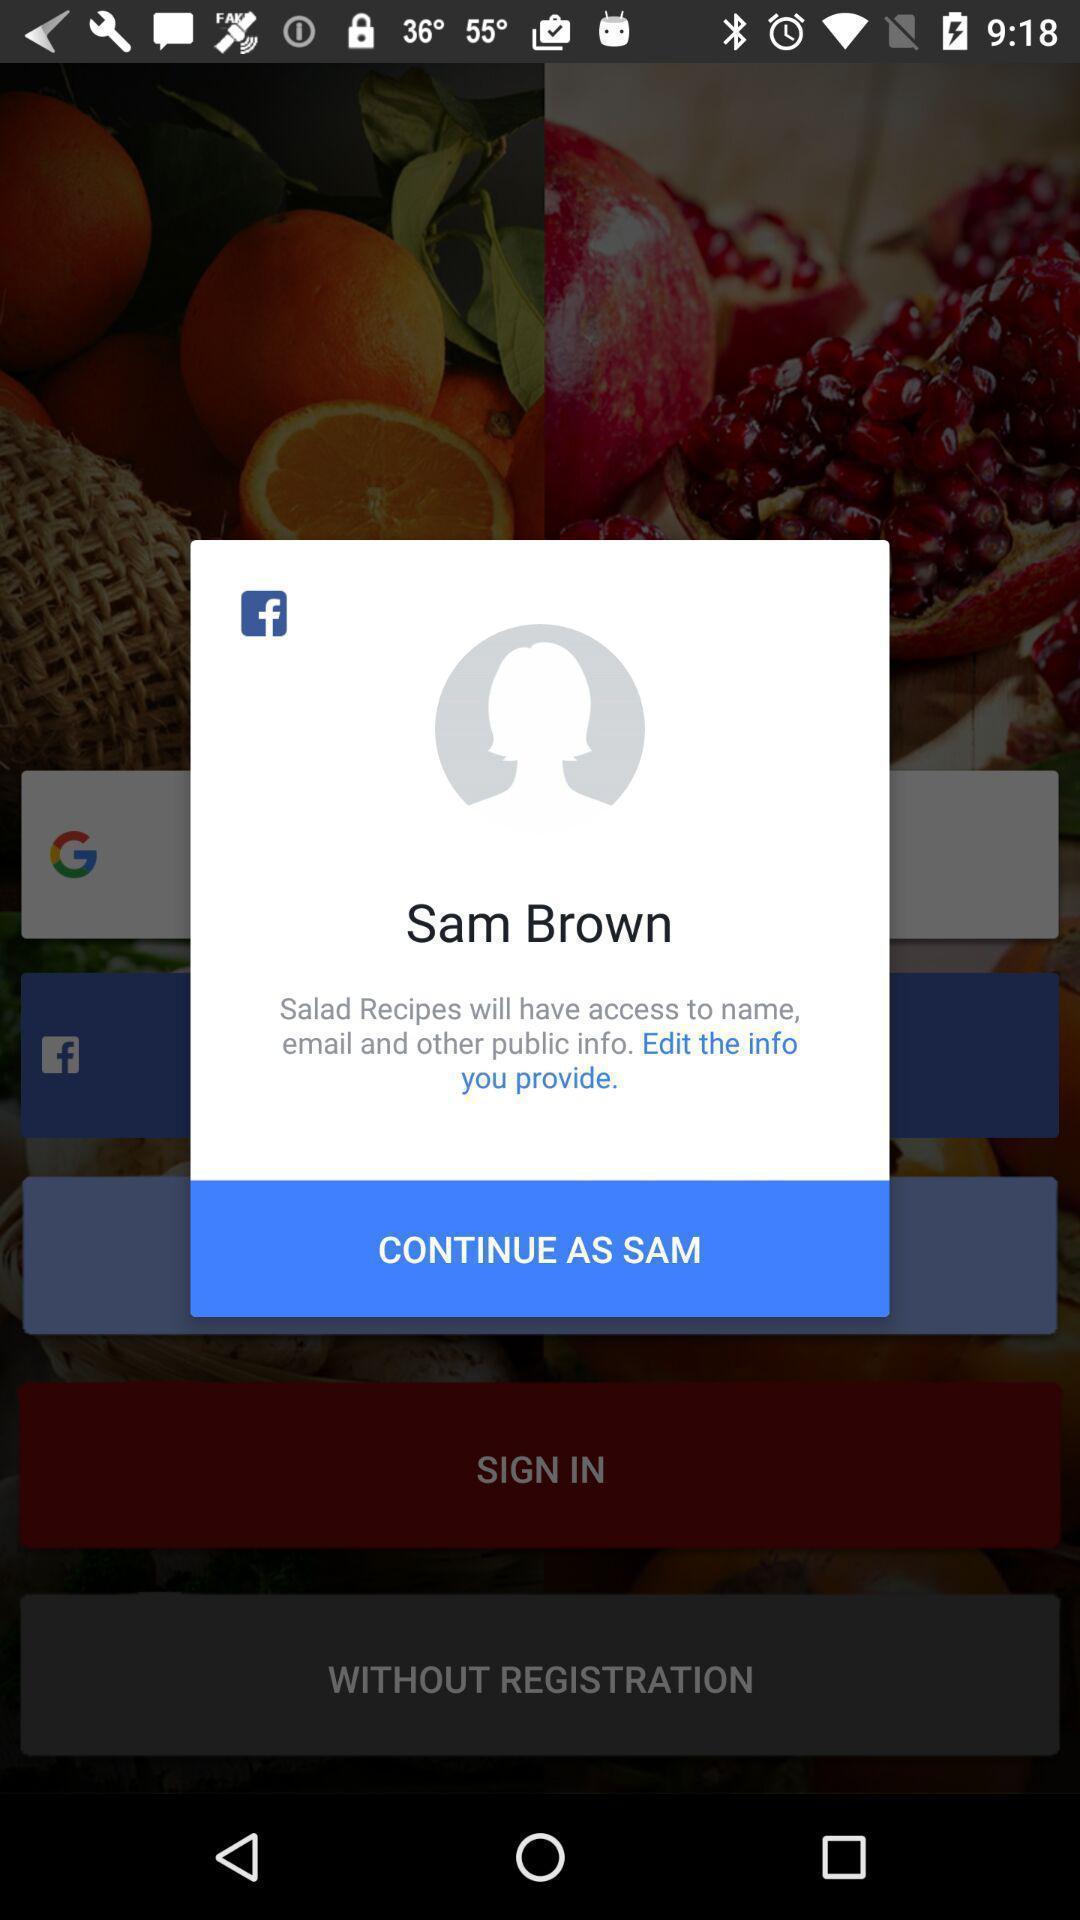Describe this image in words. Pop-up shows to continue with an app. 